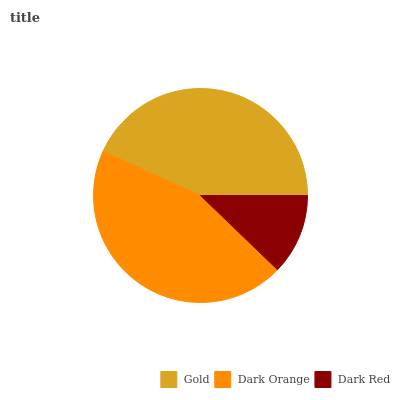Is Dark Red the minimum?
Answer yes or no. Yes. Is Dark Orange the maximum?
Answer yes or no. Yes. Is Dark Orange the minimum?
Answer yes or no. No. Is Dark Red the maximum?
Answer yes or no. No. Is Dark Orange greater than Dark Red?
Answer yes or no. Yes. Is Dark Red less than Dark Orange?
Answer yes or no. Yes. Is Dark Red greater than Dark Orange?
Answer yes or no. No. Is Dark Orange less than Dark Red?
Answer yes or no. No. Is Gold the high median?
Answer yes or no. Yes. Is Gold the low median?
Answer yes or no. Yes. Is Dark Red the high median?
Answer yes or no. No. Is Dark Orange the low median?
Answer yes or no. No. 